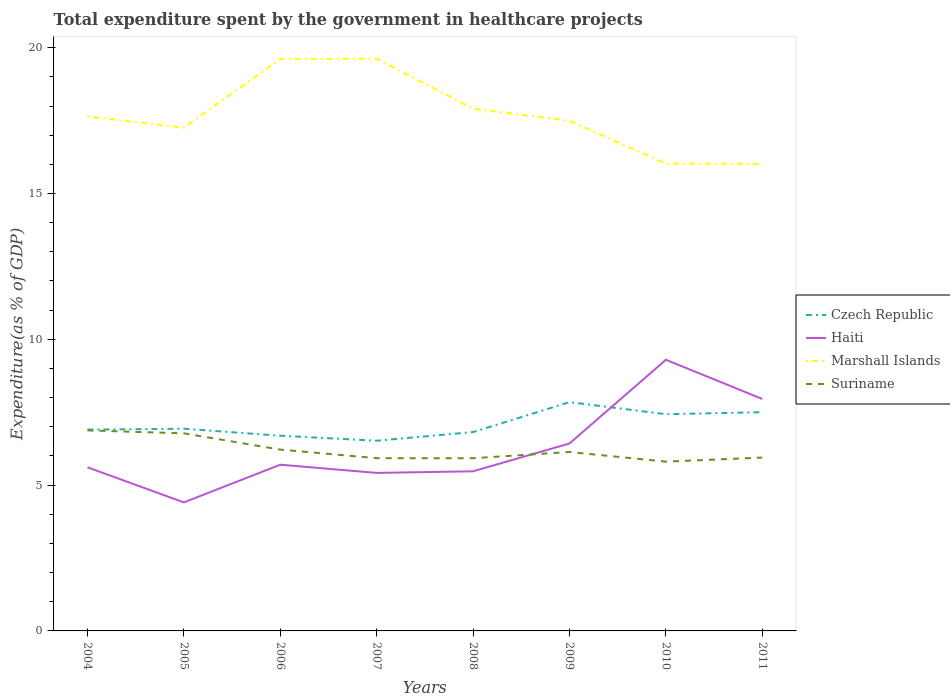Does the line corresponding to Suriname intersect with the line corresponding to Haiti?
Offer a terse response. Yes. Across all years, what is the maximum total expenditure spent by the government in healthcare projects in Marshall Islands?
Offer a terse response. 16.02. In which year was the total expenditure spent by the government in healthcare projects in Haiti maximum?
Your answer should be compact. 2005. What is the total total expenditure spent by the government in healthcare projects in Suriname in the graph?
Your answer should be very brief. 0.41. What is the difference between the highest and the second highest total expenditure spent by the government in healthcare projects in Haiti?
Make the answer very short. 4.89. What is the difference between the highest and the lowest total expenditure spent by the government in healthcare projects in Czech Republic?
Ensure brevity in your answer.  3. Are the values on the major ticks of Y-axis written in scientific E-notation?
Keep it short and to the point. No. Does the graph contain any zero values?
Offer a very short reply. No. Does the graph contain grids?
Your answer should be very brief. No. How many legend labels are there?
Make the answer very short. 4. How are the legend labels stacked?
Offer a very short reply. Vertical. What is the title of the graph?
Provide a succinct answer. Total expenditure spent by the government in healthcare projects. Does "Morocco" appear as one of the legend labels in the graph?
Make the answer very short. No. What is the label or title of the X-axis?
Offer a very short reply. Years. What is the label or title of the Y-axis?
Offer a very short reply. Expenditure(as % of GDP). What is the Expenditure(as % of GDP) of Czech Republic in 2004?
Ensure brevity in your answer.  6.9. What is the Expenditure(as % of GDP) of Haiti in 2004?
Your answer should be compact. 5.61. What is the Expenditure(as % of GDP) in Marshall Islands in 2004?
Offer a very short reply. 17.64. What is the Expenditure(as % of GDP) in Suriname in 2004?
Offer a very short reply. 6.88. What is the Expenditure(as % of GDP) in Czech Republic in 2005?
Keep it short and to the point. 6.93. What is the Expenditure(as % of GDP) of Haiti in 2005?
Offer a terse response. 4.41. What is the Expenditure(as % of GDP) of Marshall Islands in 2005?
Your answer should be compact. 17.26. What is the Expenditure(as % of GDP) in Suriname in 2005?
Make the answer very short. 6.78. What is the Expenditure(as % of GDP) in Czech Republic in 2006?
Make the answer very short. 6.69. What is the Expenditure(as % of GDP) of Haiti in 2006?
Your answer should be compact. 5.7. What is the Expenditure(as % of GDP) of Marshall Islands in 2006?
Keep it short and to the point. 19.62. What is the Expenditure(as % of GDP) of Suriname in 2006?
Offer a terse response. 6.22. What is the Expenditure(as % of GDP) in Czech Republic in 2007?
Offer a terse response. 6.52. What is the Expenditure(as % of GDP) in Haiti in 2007?
Keep it short and to the point. 5.42. What is the Expenditure(as % of GDP) in Marshall Islands in 2007?
Your answer should be very brief. 19.62. What is the Expenditure(as % of GDP) in Suriname in 2007?
Ensure brevity in your answer.  5.92. What is the Expenditure(as % of GDP) in Czech Republic in 2008?
Offer a very short reply. 6.82. What is the Expenditure(as % of GDP) of Haiti in 2008?
Offer a very short reply. 5.47. What is the Expenditure(as % of GDP) of Marshall Islands in 2008?
Offer a terse response. 17.91. What is the Expenditure(as % of GDP) of Suriname in 2008?
Your answer should be compact. 5.92. What is the Expenditure(as % of GDP) in Czech Republic in 2009?
Provide a short and direct response. 7.85. What is the Expenditure(as % of GDP) in Haiti in 2009?
Offer a very short reply. 6.43. What is the Expenditure(as % of GDP) of Marshall Islands in 2009?
Offer a terse response. 17.49. What is the Expenditure(as % of GDP) of Suriname in 2009?
Offer a terse response. 6.14. What is the Expenditure(as % of GDP) of Czech Republic in 2010?
Ensure brevity in your answer.  7.43. What is the Expenditure(as % of GDP) in Haiti in 2010?
Keep it short and to the point. 9.3. What is the Expenditure(as % of GDP) in Marshall Islands in 2010?
Your answer should be very brief. 16.03. What is the Expenditure(as % of GDP) of Suriname in 2010?
Offer a terse response. 5.81. What is the Expenditure(as % of GDP) in Czech Republic in 2011?
Provide a short and direct response. 7.5. What is the Expenditure(as % of GDP) in Haiti in 2011?
Your answer should be compact. 7.95. What is the Expenditure(as % of GDP) of Marshall Islands in 2011?
Make the answer very short. 16.02. What is the Expenditure(as % of GDP) of Suriname in 2011?
Give a very brief answer. 5.94. Across all years, what is the maximum Expenditure(as % of GDP) of Czech Republic?
Make the answer very short. 7.85. Across all years, what is the maximum Expenditure(as % of GDP) in Haiti?
Provide a succinct answer. 9.3. Across all years, what is the maximum Expenditure(as % of GDP) in Marshall Islands?
Offer a terse response. 19.62. Across all years, what is the maximum Expenditure(as % of GDP) in Suriname?
Provide a short and direct response. 6.88. Across all years, what is the minimum Expenditure(as % of GDP) in Czech Republic?
Make the answer very short. 6.52. Across all years, what is the minimum Expenditure(as % of GDP) in Haiti?
Ensure brevity in your answer.  4.41. Across all years, what is the minimum Expenditure(as % of GDP) of Marshall Islands?
Give a very brief answer. 16.02. Across all years, what is the minimum Expenditure(as % of GDP) in Suriname?
Ensure brevity in your answer.  5.81. What is the total Expenditure(as % of GDP) of Czech Republic in the graph?
Keep it short and to the point. 56.65. What is the total Expenditure(as % of GDP) of Haiti in the graph?
Your answer should be very brief. 50.29. What is the total Expenditure(as % of GDP) of Marshall Islands in the graph?
Offer a very short reply. 141.58. What is the total Expenditure(as % of GDP) in Suriname in the graph?
Make the answer very short. 49.6. What is the difference between the Expenditure(as % of GDP) of Czech Republic in 2004 and that in 2005?
Your response must be concise. -0.03. What is the difference between the Expenditure(as % of GDP) in Haiti in 2004 and that in 2005?
Keep it short and to the point. 1.2. What is the difference between the Expenditure(as % of GDP) of Marshall Islands in 2004 and that in 2005?
Your response must be concise. 0.38. What is the difference between the Expenditure(as % of GDP) in Suriname in 2004 and that in 2005?
Your response must be concise. 0.1. What is the difference between the Expenditure(as % of GDP) in Czech Republic in 2004 and that in 2006?
Your answer should be compact. 0.21. What is the difference between the Expenditure(as % of GDP) of Haiti in 2004 and that in 2006?
Make the answer very short. -0.09. What is the difference between the Expenditure(as % of GDP) in Marshall Islands in 2004 and that in 2006?
Your response must be concise. -1.97. What is the difference between the Expenditure(as % of GDP) in Suriname in 2004 and that in 2006?
Provide a short and direct response. 0.66. What is the difference between the Expenditure(as % of GDP) in Czech Republic in 2004 and that in 2007?
Your answer should be compact. 0.38. What is the difference between the Expenditure(as % of GDP) in Haiti in 2004 and that in 2007?
Your answer should be compact. 0.19. What is the difference between the Expenditure(as % of GDP) in Marshall Islands in 2004 and that in 2007?
Your response must be concise. -1.98. What is the difference between the Expenditure(as % of GDP) of Suriname in 2004 and that in 2007?
Offer a terse response. 0.95. What is the difference between the Expenditure(as % of GDP) in Czech Republic in 2004 and that in 2008?
Offer a very short reply. 0.08. What is the difference between the Expenditure(as % of GDP) in Haiti in 2004 and that in 2008?
Your response must be concise. 0.14. What is the difference between the Expenditure(as % of GDP) of Marshall Islands in 2004 and that in 2008?
Offer a terse response. -0.27. What is the difference between the Expenditure(as % of GDP) of Suriname in 2004 and that in 2008?
Offer a terse response. 0.95. What is the difference between the Expenditure(as % of GDP) in Czech Republic in 2004 and that in 2009?
Offer a terse response. -0.94. What is the difference between the Expenditure(as % of GDP) of Haiti in 2004 and that in 2009?
Give a very brief answer. -0.82. What is the difference between the Expenditure(as % of GDP) of Marshall Islands in 2004 and that in 2009?
Provide a succinct answer. 0.15. What is the difference between the Expenditure(as % of GDP) in Suriname in 2004 and that in 2009?
Provide a short and direct response. 0.74. What is the difference between the Expenditure(as % of GDP) in Czech Republic in 2004 and that in 2010?
Make the answer very short. -0.53. What is the difference between the Expenditure(as % of GDP) in Haiti in 2004 and that in 2010?
Your response must be concise. -3.69. What is the difference between the Expenditure(as % of GDP) in Marshall Islands in 2004 and that in 2010?
Make the answer very short. 1.62. What is the difference between the Expenditure(as % of GDP) in Suriname in 2004 and that in 2010?
Your answer should be compact. 1.07. What is the difference between the Expenditure(as % of GDP) of Czech Republic in 2004 and that in 2011?
Make the answer very short. -0.6. What is the difference between the Expenditure(as % of GDP) of Haiti in 2004 and that in 2011?
Make the answer very short. -2.34. What is the difference between the Expenditure(as % of GDP) of Marshall Islands in 2004 and that in 2011?
Your answer should be very brief. 1.62. What is the difference between the Expenditure(as % of GDP) in Suriname in 2004 and that in 2011?
Offer a terse response. 0.93. What is the difference between the Expenditure(as % of GDP) of Czech Republic in 2005 and that in 2006?
Offer a terse response. 0.24. What is the difference between the Expenditure(as % of GDP) in Haiti in 2005 and that in 2006?
Your answer should be very brief. -1.29. What is the difference between the Expenditure(as % of GDP) of Marshall Islands in 2005 and that in 2006?
Give a very brief answer. -2.36. What is the difference between the Expenditure(as % of GDP) in Suriname in 2005 and that in 2006?
Your answer should be compact. 0.56. What is the difference between the Expenditure(as % of GDP) of Czech Republic in 2005 and that in 2007?
Your response must be concise. 0.41. What is the difference between the Expenditure(as % of GDP) in Haiti in 2005 and that in 2007?
Provide a succinct answer. -1.01. What is the difference between the Expenditure(as % of GDP) in Marshall Islands in 2005 and that in 2007?
Provide a short and direct response. -2.36. What is the difference between the Expenditure(as % of GDP) in Suriname in 2005 and that in 2007?
Provide a succinct answer. 0.85. What is the difference between the Expenditure(as % of GDP) of Czech Republic in 2005 and that in 2008?
Provide a short and direct response. 0.12. What is the difference between the Expenditure(as % of GDP) in Haiti in 2005 and that in 2008?
Give a very brief answer. -1.07. What is the difference between the Expenditure(as % of GDP) of Marshall Islands in 2005 and that in 2008?
Your response must be concise. -0.65. What is the difference between the Expenditure(as % of GDP) of Suriname in 2005 and that in 2008?
Provide a short and direct response. 0.85. What is the difference between the Expenditure(as % of GDP) of Czech Republic in 2005 and that in 2009?
Provide a short and direct response. -0.91. What is the difference between the Expenditure(as % of GDP) in Haiti in 2005 and that in 2009?
Ensure brevity in your answer.  -2.02. What is the difference between the Expenditure(as % of GDP) in Marshall Islands in 2005 and that in 2009?
Ensure brevity in your answer.  -0.24. What is the difference between the Expenditure(as % of GDP) of Suriname in 2005 and that in 2009?
Provide a succinct answer. 0.64. What is the difference between the Expenditure(as % of GDP) in Czech Republic in 2005 and that in 2010?
Your response must be concise. -0.5. What is the difference between the Expenditure(as % of GDP) in Haiti in 2005 and that in 2010?
Offer a very short reply. -4.89. What is the difference between the Expenditure(as % of GDP) of Marshall Islands in 2005 and that in 2010?
Your response must be concise. 1.23. What is the difference between the Expenditure(as % of GDP) of Suriname in 2005 and that in 2010?
Your answer should be compact. 0.97. What is the difference between the Expenditure(as % of GDP) of Czech Republic in 2005 and that in 2011?
Give a very brief answer. -0.57. What is the difference between the Expenditure(as % of GDP) in Haiti in 2005 and that in 2011?
Keep it short and to the point. -3.55. What is the difference between the Expenditure(as % of GDP) in Marshall Islands in 2005 and that in 2011?
Your answer should be compact. 1.24. What is the difference between the Expenditure(as % of GDP) in Suriname in 2005 and that in 2011?
Give a very brief answer. 0.83. What is the difference between the Expenditure(as % of GDP) of Czech Republic in 2006 and that in 2007?
Offer a very short reply. 0.17. What is the difference between the Expenditure(as % of GDP) in Haiti in 2006 and that in 2007?
Give a very brief answer. 0.28. What is the difference between the Expenditure(as % of GDP) in Marshall Islands in 2006 and that in 2007?
Provide a succinct answer. -0. What is the difference between the Expenditure(as % of GDP) of Suriname in 2006 and that in 2007?
Keep it short and to the point. 0.29. What is the difference between the Expenditure(as % of GDP) in Czech Republic in 2006 and that in 2008?
Offer a terse response. -0.13. What is the difference between the Expenditure(as % of GDP) of Haiti in 2006 and that in 2008?
Your response must be concise. 0.23. What is the difference between the Expenditure(as % of GDP) of Marshall Islands in 2006 and that in 2008?
Your answer should be compact. 1.71. What is the difference between the Expenditure(as % of GDP) of Suriname in 2006 and that in 2008?
Offer a very short reply. 0.29. What is the difference between the Expenditure(as % of GDP) of Czech Republic in 2006 and that in 2009?
Provide a succinct answer. -1.15. What is the difference between the Expenditure(as % of GDP) of Haiti in 2006 and that in 2009?
Ensure brevity in your answer.  -0.73. What is the difference between the Expenditure(as % of GDP) of Marshall Islands in 2006 and that in 2009?
Your response must be concise. 2.12. What is the difference between the Expenditure(as % of GDP) in Suriname in 2006 and that in 2009?
Provide a succinct answer. 0.08. What is the difference between the Expenditure(as % of GDP) of Czech Republic in 2006 and that in 2010?
Keep it short and to the point. -0.74. What is the difference between the Expenditure(as % of GDP) of Haiti in 2006 and that in 2010?
Your answer should be very brief. -3.6. What is the difference between the Expenditure(as % of GDP) of Marshall Islands in 2006 and that in 2010?
Make the answer very short. 3.59. What is the difference between the Expenditure(as % of GDP) of Suriname in 2006 and that in 2010?
Offer a terse response. 0.41. What is the difference between the Expenditure(as % of GDP) of Czech Republic in 2006 and that in 2011?
Your answer should be very brief. -0.81. What is the difference between the Expenditure(as % of GDP) of Haiti in 2006 and that in 2011?
Offer a very short reply. -2.26. What is the difference between the Expenditure(as % of GDP) of Marshall Islands in 2006 and that in 2011?
Offer a terse response. 3.6. What is the difference between the Expenditure(as % of GDP) in Suriname in 2006 and that in 2011?
Your answer should be very brief. 0.27. What is the difference between the Expenditure(as % of GDP) of Czech Republic in 2007 and that in 2008?
Your answer should be very brief. -0.3. What is the difference between the Expenditure(as % of GDP) in Haiti in 2007 and that in 2008?
Give a very brief answer. -0.06. What is the difference between the Expenditure(as % of GDP) in Marshall Islands in 2007 and that in 2008?
Ensure brevity in your answer.  1.71. What is the difference between the Expenditure(as % of GDP) in Suriname in 2007 and that in 2008?
Provide a short and direct response. 0. What is the difference between the Expenditure(as % of GDP) in Czech Republic in 2007 and that in 2009?
Give a very brief answer. -1.32. What is the difference between the Expenditure(as % of GDP) of Haiti in 2007 and that in 2009?
Make the answer very short. -1.01. What is the difference between the Expenditure(as % of GDP) in Marshall Islands in 2007 and that in 2009?
Make the answer very short. 2.13. What is the difference between the Expenditure(as % of GDP) of Suriname in 2007 and that in 2009?
Offer a terse response. -0.21. What is the difference between the Expenditure(as % of GDP) in Czech Republic in 2007 and that in 2010?
Ensure brevity in your answer.  -0.91. What is the difference between the Expenditure(as % of GDP) in Haiti in 2007 and that in 2010?
Make the answer very short. -3.88. What is the difference between the Expenditure(as % of GDP) of Marshall Islands in 2007 and that in 2010?
Ensure brevity in your answer.  3.59. What is the difference between the Expenditure(as % of GDP) of Suriname in 2007 and that in 2010?
Ensure brevity in your answer.  0.12. What is the difference between the Expenditure(as % of GDP) of Czech Republic in 2007 and that in 2011?
Provide a short and direct response. -0.98. What is the difference between the Expenditure(as % of GDP) of Haiti in 2007 and that in 2011?
Provide a succinct answer. -2.54. What is the difference between the Expenditure(as % of GDP) of Marshall Islands in 2007 and that in 2011?
Offer a very short reply. 3.6. What is the difference between the Expenditure(as % of GDP) in Suriname in 2007 and that in 2011?
Your response must be concise. -0.02. What is the difference between the Expenditure(as % of GDP) of Czech Republic in 2008 and that in 2009?
Make the answer very short. -1.03. What is the difference between the Expenditure(as % of GDP) in Haiti in 2008 and that in 2009?
Keep it short and to the point. -0.95. What is the difference between the Expenditure(as % of GDP) of Marshall Islands in 2008 and that in 2009?
Provide a succinct answer. 0.41. What is the difference between the Expenditure(as % of GDP) of Suriname in 2008 and that in 2009?
Offer a terse response. -0.21. What is the difference between the Expenditure(as % of GDP) in Czech Republic in 2008 and that in 2010?
Provide a short and direct response. -0.61. What is the difference between the Expenditure(as % of GDP) in Haiti in 2008 and that in 2010?
Offer a very short reply. -3.82. What is the difference between the Expenditure(as % of GDP) of Marshall Islands in 2008 and that in 2010?
Offer a terse response. 1.88. What is the difference between the Expenditure(as % of GDP) of Suriname in 2008 and that in 2010?
Provide a short and direct response. 0.12. What is the difference between the Expenditure(as % of GDP) in Czech Republic in 2008 and that in 2011?
Your answer should be compact. -0.68. What is the difference between the Expenditure(as % of GDP) in Haiti in 2008 and that in 2011?
Your answer should be very brief. -2.48. What is the difference between the Expenditure(as % of GDP) in Marshall Islands in 2008 and that in 2011?
Offer a very short reply. 1.89. What is the difference between the Expenditure(as % of GDP) of Suriname in 2008 and that in 2011?
Provide a succinct answer. -0.02. What is the difference between the Expenditure(as % of GDP) in Czech Republic in 2009 and that in 2010?
Offer a terse response. 0.41. What is the difference between the Expenditure(as % of GDP) of Haiti in 2009 and that in 2010?
Offer a very short reply. -2.87. What is the difference between the Expenditure(as % of GDP) of Marshall Islands in 2009 and that in 2010?
Provide a succinct answer. 1.47. What is the difference between the Expenditure(as % of GDP) in Suriname in 2009 and that in 2010?
Ensure brevity in your answer.  0.33. What is the difference between the Expenditure(as % of GDP) of Czech Republic in 2009 and that in 2011?
Your answer should be very brief. 0.34. What is the difference between the Expenditure(as % of GDP) of Haiti in 2009 and that in 2011?
Ensure brevity in your answer.  -1.53. What is the difference between the Expenditure(as % of GDP) in Marshall Islands in 2009 and that in 2011?
Provide a succinct answer. 1.47. What is the difference between the Expenditure(as % of GDP) of Suriname in 2009 and that in 2011?
Offer a very short reply. 0.19. What is the difference between the Expenditure(as % of GDP) of Czech Republic in 2010 and that in 2011?
Give a very brief answer. -0.07. What is the difference between the Expenditure(as % of GDP) of Haiti in 2010 and that in 2011?
Keep it short and to the point. 1.34. What is the difference between the Expenditure(as % of GDP) of Marshall Islands in 2010 and that in 2011?
Give a very brief answer. 0.01. What is the difference between the Expenditure(as % of GDP) in Suriname in 2010 and that in 2011?
Your answer should be very brief. -0.14. What is the difference between the Expenditure(as % of GDP) in Czech Republic in 2004 and the Expenditure(as % of GDP) in Haiti in 2005?
Offer a terse response. 2.5. What is the difference between the Expenditure(as % of GDP) in Czech Republic in 2004 and the Expenditure(as % of GDP) in Marshall Islands in 2005?
Your answer should be very brief. -10.35. What is the difference between the Expenditure(as % of GDP) of Czech Republic in 2004 and the Expenditure(as % of GDP) of Suriname in 2005?
Make the answer very short. 0.13. What is the difference between the Expenditure(as % of GDP) in Haiti in 2004 and the Expenditure(as % of GDP) in Marshall Islands in 2005?
Offer a terse response. -11.65. What is the difference between the Expenditure(as % of GDP) in Haiti in 2004 and the Expenditure(as % of GDP) in Suriname in 2005?
Your answer should be very brief. -1.16. What is the difference between the Expenditure(as % of GDP) of Marshall Islands in 2004 and the Expenditure(as % of GDP) of Suriname in 2005?
Provide a succinct answer. 10.87. What is the difference between the Expenditure(as % of GDP) in Czech Republic in 2004 and the Expenditure(as % of GDP) in Haiti in 2006?
Ensure brevity in your answer.  1.2. What is the difference between the Expenditure(as % of GDP) of Czech Republic in 2004 and the Expenditure(as % of GDP) of Marshall Islands in 2006?
Provide a succinct answer. -12.71. What is the difference between the Expenditure(as % of GDP) in Czech Republic in 2004 and the Expenditure(as % of GDP) in Suriname in 2006?
Your answer should be compact. 0.69. What is the difference between the Expenditure(as % of GDP) in Haiti in 2004 and the Expenditure(as % of GDP) in Marshall Islands in 2006?
Provide a succinct answer. -14.01. What is the difference between the Expenditure(as % of GDP) in Haiti in 2004 and the Expenditure(as % of GDP) in Suriname in 2006?
Offer a terse response. -0.61. What is the difference between the Expenditure(as % of GDP) in Marshall Islands in 2004 and the Expenditure(as % of GDP) in Suriname in 2006?
Make the answer very short. 11.42. What is the difference between the Expenditure(as % of GDP) in Czech Republic in 2004 and the Expenditure(as % of GDP) in Haiti in 2007?
Give a very brief answer. 1.49. What is the difference between the Expenditure(as % of GDP) of Czech Republic in 2004 and the Expenditure(as % of GDP) of Marshall Islands in 2007?
Your answer should be compact. -12.72. What is the difference between the Expenditure(as % of GDP) in Czech Republic in 2004 and the Expenditure(as % of GDP) in Suriname in 2007?
Make the answer very short. 0.98. What is the difference between the Expenditure(as % of GDP) in Haiti in 2004 and the Expenditure(as % of GDP) in Marshall Islands in 2007?
Make the answer very short. -14.01. What is the difference between the Expenditure(as % of GDP) in Haiti in 2004 and the Expenditure(as % of GDP) in Suriname in 2007?
Your answer should be very brief. -0.31. What is the difference between the Expenditure(as % of GDP) in Marshall Islands in 2004 and the Expenditure(as % of GDP) in Suriname in 2007?
Your answer should be very brief. 11.72. What is the difference between the Expenditure(as % of GDP) of Czech Republic in 2004 and the Expenditure(as % of GDP) of Haiti in 2008?
Offer a very short reply. 1.43. What is the difference between the Expenditure(as % of GDP) in Czech Republic in 2004 and the Expenditure(as % of GDP) in Marshall Islands in 2008?
Your response must be concise. -11. What is the difference between the Expenditure(as % of GDP) in Czech Republic in 2004 and the Expenditure(as % of GDP) in Suriname in 2008?
Offer a terse response. 0.98. What is the difference between the Expenditure(as % of GDP) of Haiti in 2004 and the Expenditure(as % of GDP) of Marshall Islands in 2008?
Provide a short and direct response. -12.3. What is the difference between the Expenditure(as % of GDP) of Haiti in 2004 and the Expenditure(as % of GDP) of Suriname in 2008?
Make the answer very short. -0.31. What is the difference between the Expenditure(as % of GDP) of Marshall Islands in 2004 and the Expenditure(as % of GDP) of Suriname in 2008?
Your answer should be compact. 11.72. What is the difference between the Expenditure(as % of GDP) in Czech Republic in 2004 and the Expenditure(as % of GDP) in Haiti in 2009?
Ensure brevity in your answer.  0.48. What is the difference between the Expenditure(as % of GDP) in Czech Republic in 2004 and the Expenditure(as % of GDP) in Marshall Islands in 2009?
Provide a short and direct response. -10.59. What is the difference between the Expenditure(as % of GDP) of Czech Republic in 2004 and the Expenditure(as % of GDP) of Suriname in 2009?
Offer a very short reply. 0.77. What is the difference between the Expenditure(as % of GDP) in Haiti in 2004 and the Expenditure(as % of GDP) in Marshall Islands in 2009?
Your answer should be compact. -11.88. What is the difference between the Expenditure(as % of GDP) of Haiti in 2004 and the Expenditure(as % of GDP) of Suriname in 2009?
Give a very brief answer. -0.52. What is the difference between the Expenditure(as % of GDP) of Marshall Islands in 2004 and the Expenditure(as % of GDP) of Suriname in 2009?
Keep it short and to the point. 11.51. What is the difference between the Expenditure(as % of GDP) of Czech Republic in 2004 and the Expenditure(as % of GDP) of Haiti in 2010?
Provide a succinct answer. -2.39. What is the difference between the Expenditure(as % of GDP) in Czech Republic in 2004 and the Expenditure(as % of GDP) in Marshall Islands in 2010?
Make the answer very short. -9.12. What is the difference between the Expenditure(as % of GDP) of Czech Republic in 2004 and the Expenditure(as % of GDP) of Suriname in 2010?
Keep it short and to the point. 1.1. What is the difference between the Expenditure(as % of GDP) in Haiti in 2004 and the Expenditure(as % of GDP) in Marshall Islands in 2010?
Give a very brief answer. -10.41. What is the difference between the Expenditure(as % of GDP) in Haiti in 2004 and the Expenditure(as % of GDP) in Suriname in 2010?
Offer a terse response. -0.19. What is the difference between the Expenditure(as % of GDP) in Marshall Islands in 2004 and the Expenditure(as % of GDP) in Suriname in 2010?
Give a very brief answer. 11.84. What is the difference between the Expenditure(as % of GDP) of Czech Republic in 2004 and the Expenditure(as % of GDP) of Haiti in 2011?
Provide a succinct answer. -1.05. What is the difference between the Expenditure(as % of GDP) of Czech Republic in 2004 and the Expenditure(as % of GDP) of Marshall Islands in 2011?
Your response must be concise. -9.12. What is the difference between the Expenditure(as % of GDP) in Czech Republic in 2004 and the Expenditure(as % of GDP) in Suriname in 2011?
Provide a succinct answer. 0.96. What is the difference between the Expenditure(as % of GDP) of Haiti in 2004 and the Expenditure(as % of GDP) of Marshall Islands in 2011?
Give a very brief answer. -10.41. What is the difference between the Expenditure(as % of GDP) in Haiti in 2004 and the Expenditure(as % of GDP) in Suriname in 2011?
Keep it short and to the point. -0.33. What is the difference between the Expenditure(as % of GDP) of Marshall Islands in 2004 and the Expenditure(as % of GDP) of Suriname in 2011?
Your answer should be compact. 11.7. What is the difference between the Expenditure(as % of GDP) in Czech Republic in 2005 and the Expenditure(as % of GDP) in Haiti in 2006?
Ensure brevity in your answer.  1.23. What is the difference between the Expenditure(as % of GDP) in Czech Republic in 2005 and the Expenditure(as % of GDP) in Marshall Islands in 2006?
Provide a short and direct response. -12.68. What is the difference between the Expenditure(as % of GDP) of Czech Republic in 2005 and the Expenditure(as % of GDP) of Suriname in 2006?
Provide a short and direct response. 0.72. What is the difference between the Expenditure(as % of GDP) in Haiti in 2005 and the Expenditure(as % of GDP) in Marshall Islands in 2006?
Keep it short and to the point. -15.21. What is the difference between the Expenditure(as % of GDP) of Haiti in 2005 and the Expenditure(as % of GDP) of Suriname in 2006?
Your response must be concise. -1.81. What is the difference between the Expenditure(as % of GDP) of Marshall Islands in 2005 and the Expenditure(as % of GDP) of Suriname in 2006?
Keep it short and to the point. 11.04. What is the difference between the Expenditure(as % of GDP) of Czech Republic in 2005 and the Expenditure(as % of GDP) of Haiti in 2007?
Your answer should be compact. 1.52. What is the difference between the Expenditure(as % of GDP) of Czech Republic in 2005 and the Expenditure(as % of GDP) of Marshall Islands in 2007?
Offer a terse response. -12.69. What is the difference between the Expenditure(as % of GDP) of Haiti in 2005 and the Expenditure(as % of GDP) of Marshall Islands in 2007?
Make the answer very short. -15.21. What is the difference between the Expenditure(as % of GDP) of Haiti in 2005 and the Expenditure(as % of GDP) of Suriname in 2007?
Ensure brevity in your answer.  -1.52. What is the difference between the Expenditure(as % of GDP) of Marshall Islands in 2005 and the Expenditure(as % of GDP) of Suriname in 2007?
Make the answer very short. 11.33. What is the difference between the Expenditure(as % of GDP) of Czech Republic in 2005 and the Expenditure(as % of GDP) of Haiti in 2008?
Your response must be concise. 1.46. What is the difference between the Expenditure(as % of GDP) in Czech Republic in 2005 and the Expenditure(as % of GDP) in Marshall Islands in 2008?
Ensure brevity in your answer.  -10.97. What is the difference between the Expenditure(as % of GDP) in Czech Republic in 2005 and the Expenditure(as % of GDP) in Suriname in 2008?
Your answer should be compact. 1.01. What is the difference between the Expenditure(as % of GDP) in Haiti in 2005 and the Expenditure(as % of GDP) in Marshall Islands in 2008?
Your response must be concise. -13.5. What is the difference between the Expenditure(as % of GDP) in Haiti in 2005 and the Expenditure(as % of GDP) in Suriname in 2008?
Ensure brevity in your answer.  -1.51. What is the difference between the Expenditure(as % of GDP) in Marshall Islands in 2005 and the Expenditure(as % of GDP) in Suriname in 2008?
Provide a short and direct response. 11.33. What is the difference between the Expenditure(as % of GDP) in Czech Republic in 2005 and the Expenditure(as % of GDP) in Haiti in 2009?
Give a very brief answer. 0.51. What is the difference between the Expenditure(as % of GDP) in Czech Republic in 2005 and the Expenditure(as % of GDP) in Marshall Islands in 2009?
Give a very brief answer. -10.56. What is the difference between the Expenditure(as % of GDP) of Czech Republic in 2005 and the Expenditure(as % of GDP) of Suriname in 2009?
Keep it short and to the point. 0.8. What is the difference between the Expenditure(as % of GDP) of Haiti in 2005 and the Expenditure(as % of GDP) of Marshall Islands in 2009?
Give a very brief answer. -13.09. What is the difference between the Expenditure(as % of GDP) in Haiti in 2005 and the Expenditure(as % of GDP) in Suriname in 2009?
Keep it short and to the point. -1.73. What is the difference between the Expenditure(as % of GDP) of Marshall Islands in 2005 and the Expenditure(as % of GDP) of Suriname in 2009?
Your response must be concise. 11.12. What is the difference between the Expenditure(as % of GDP) in Czech Republic in 2005 and the Expenditure(as % of GDP) in Haiti in 2010?
Your response must be concise. -2.36. What is the difference between the Expenditure(as % of GDP) in Czech Republic in 2005 and the Expenditure(as % of GDP) in Marshall Islands in 2010?
Provide a succinct answer. -9.09. What is the difference between the Expenditure(as % of GDP) in Czech Republic in 2005 and the Expenditure(as % of GDP) in Suriname in 2010?
Your response must be concise. 1.13. What is the difference between the Expenditure(as % of GDP) of Haiti in 2005 and the Expenditure(as % of GDP) of Marshall Islands in 2010?
Provide a short and direct response. -11.62. What is the difference between the Expenditure(as % of GDP) of Haiti in 2005 and the Expenditure(as % of GDP) of Suriname in 2010?
Your response must be concise. -1.4. What is the difference between the Expenditure(as % of GDP) in Marshall Islands in 2005 and the Expenditure(as % of GDP) in Suriname in 2010?
Provide a succinct answer. 11.45. What is the difference between the Expenditure(as % of GDP) of Czech Republic in 2005 and the Expenditure(as % of GDP) of Haiti in 2011?
Make the answer very short. -1.02. What is the difference between the Expenditure(as % of GDP) in Czech Republic in 2005 and the Expenditure(as % of GDP) in Marshall Islands in 2011?
Keep it short and to the point. -9.09. What is the difference between the Expenditure(as % of GDP) in Haiti in 2005 and the Expenditure(as % of GDP) in Marshall Islands in 2011?
Your response must be concise. -11.61. What is the difference between the Expenditure(as % of GDP) of Haiti in 2005 and the Expenditure(as % of GDP) of Suriname in 2011?
Your answer should be very brief. -1.54. What is the difference between the Expenditure(as % of GDP) of Marshall Islands in 2005 and the Expenditure(as % of GDP) of Suriname in 2011?
Keep it short and to the point. 11.31. What is the difference between the Expenditure(as % of GDP) of Czech Republic in 2006 and the Expenditure(as % of GDP) of Haiti in 2007?
Provide a succinct answer. 1.28. What is the difference between the Expenditure(as % of GDP) of Czech Republic in 2006 and the Expenditure(as % of GDP) of Marshall Islands in 2007?
Provide a succinct answer. -12.93. What is the difference between the Expenditure(as % of GDP) in Czech Republic in 2006 and the Expenditure(as % of GDP) in Suriname in 2007?
Give a very brief answer. 0.77. What is the difference between the Expenditure(as % of GDP) of Haiti in 2006 and the Expenditure(as % of GDP) of Marshall Islands in 2007?
Provide a succinct answer. -13.92. What is the difference between the Expenditure(as % of GDP) in Haiti in 2006 and the Expenditure(as % of GDP) in Suriname in 2007?
Give a very brief answer. -0.22. What is the difference between the Expenditure(as % of GDP) of Marshall Islands in 2006 and the Expenditure(as % of GDP) of Suriname in 2007?
Make the answer very short. 13.69. What is the difference between the Expenditure(as % of GDP) of Czech Republic in 2006 and the Expenditure(as % of GDP) of Haiti in 2008?
Offer a very short reply. 1.22. What is the difference between the Expenditure(as % of GDP) in Czech Republic in 2006 and the Expenditure(as % of GDP) in Marshall Islands in 2008?
Your answer should be compact. -11.21. What is the difference between the Expenditure(as % of GDP) in Czech Republic in 2006 and the Expenditure(as % of GDP) in Suriname in 2008?
Your response must be concise. 0.77. What is the difference between the Expenditure(as % of GDP) in Haiti in 2006 and the Expenditure(as % of GDP) in Marshall Islands in 2008?
Provide a succinct answer. -12.21. What is the difference between the Expenditure(as % of GDP) in Haiti in 2006 and the Expenditure(as % of GDP) in Suriname in 2008?
Make the answer very short. -0.22. What is the difference between the Expenditure(as % of GDP) in Marshall Islands in 2006 and the Expenditure(as % of GDP) in Suriname in 2008?
Your response must be concise. 13.69. What is the difference between the Expenditure(as % of GDP) in Czech Republic in 2006 and the Expenditure(as % of GDP) in Haiti in 2009?
Offer a very short reply. 0.27. What is the difference between the Expenditure(as % of GDP) of Czech Republic in 2006 and the Expenditure(as % of GDP) of Marshall Islands in 2009?
Your answer should be compact. -10.8. What is the difference between the Expenditure(as % of GDP) in Czech Republic in 2006 and the Expenditure(as % of GDP) in Suriname in 2009?
Provide a succinct answer. 0.56. What is the difference between the Expenditure(as % of GDP) in Haiti in 2006 and the Expenditure(as % of GDP) in Marshall Islands in 2009?
Make the answer very short. -11.79. What is the difference between the Expenditure(as % of GDP) of Haiti in 2006 and the Expenditure(as % of GDP) of Suriname in 2009?
Keep it short and to the point. -0.44. What is the difference between the Expenditure(as % of GDP) in Marshall Islands in 2006 and the Expenditure(as % of GDP) in Suriname in 2009?
Provide a short and direct response. 13.48. What is the difference between the Expenditure(as % of GDP) in Czech Republic in 2006 and the Expenditure(as % of GDP) in Haiti in 2010?
Ensure brevity in your answer.  -2.6. What is the difference between the Expenditure(as % of GDP) in Czech Republic in 2006 and the Expenditure(as % of GDP) in Marshall Islands in 2010?
Give a very brief answer. -9.33. What is the difference between the Expenditure(as % of GDP) of Czech Republic in 2006 and the Expenditure(as % of GDP) of Suriname in 2010?
Your response must be concise. 0.89. What is the difference between the Expenditure(as % of GDP) in Haiti in 2006 and the Expenditure(as % of GDP) in Marshall Islands in 2010?
Your response must be concise. -10.33. What is the difference between the Expenditure(as % of GDP) in Haiti in 2006 and the Expenditure(as % of GDP) in Suriname in 2010?
Your answer should be compact. -0.11. What is the difference between the Expenditure(as % of GDP) of Marshall Islands in 2006 and the Expenditure(as % of GDP) of Suriname in 2010?
Provide a succinct answer. 13.81. What is the difference between the Expenditure(as % of GDP) of Czech Republic in 2006 and the Expenditure(as % of GDP) of Haiti in 2011?
Keep it short and to the point. -1.26. What is the difference between the Expenditure(as % of GDP) in Czech Republic in 2006 and the Expenditure(as % of GDP) in Marshall Islands in 2011?
Provide a succinct answer. -9.33. What is the difference between the Expenditure(as % of GDP) in Czech Republic in 2006 and the Expenditure(as % of GDP) in Suriname in 2011?
Your response must be concise. 0.75. What is the difference between the Expenditure(as % of GDP) of Haiti in 2006 and the Expenditure(as % of GDP) of Marshall Islands in 2011?
Provide a succinct answer. -10.32. What is the difference between the Expenditure(as % of GDP) in Haiti in 2006 and the Expenditure(as % of GDP) in Suriname in 2011?
Ensure brevity in your answer.  -0.24. What is the difference between the Expenditure(as % of GDP) in Marshall Islands in 2006 and the Expenditure(as % of GDP) in Suriname in 2011?
Keep it short and to the point. 13.67. What is the difference between the Expenditure(as % of GDP) in Czech Republic in 2007 and the Expenditure(as % of GDP) in Haiti in 2008?
Offer a very short reply. 1.05. What is the difference between the Expenditure(as % of GDP) in Czech Republic in 2007 and the Expenditure(as % of GDP) in Marshall Islands in 2008?
Give a very brief answer. -11.39. What is the difference between the Expenditure(as % of GDP) of Czech Republic in 2007 and the Expenditure(as % of GDP) of Suriname in 2008?
Offer a very short reply. 0.6. What is the difference between the Expenditure(as % of GDP) of Haiti in 2007 and the Expenditure(as % of GDP) of Marshall Islands in 2008?
Your response must be concise. -12.49. What is the difference between the Expenditure(as % of GDP) of Haiti in 2007 and the Expenditure(as % of GDP) of Suriname in 2008?
Offer a very short reply. -0.5. What is the difference between the Expenditure(as % of GDP) of Marshall Islands in 2007 and the Expenditure(as % of GDP) of Suriname in 2008?
Offer a terse response. 13.7. What is the difference between the Expenditure(as % of GDP) in Czech Republic in 2007 and the Expenditure(as % of GDP) in Haiti in 2009?
Your response must be concise. 0.09. What is the difference between the Expenditure(as % of GDP) in Czech Republic in 2007 and the Expenditure(as % of GDP) in Marshall Islands in 2009?
Offer a terse response. -10.97. What is the difference between the Expenditure(as % of GDP) of Czech Republic in 2007 and the Expenditure(as % of GDP) of Suriname in 2009?
Offer a very short reply. 0.39. What is the difference between the Expenditure(as % of GDP) of Haiti in 2007 and the Expenditure(as % of GDP) of Marshall Islands in 2009?
Ensure brevity in your answer.  -12.08. What is the difference between the Expenditure(as % of GDP) in Haiti in 2007 and the Expenditure(as % of GDP) in Suriname in 2009?
Offer a very short reply. -0.72. What is the difference between the Expenditure(as % of GDP) in Marshall Islands in 2007 and the Expenditure(as % of GDP) in Suriname in 2009?
Make the answer very short. 13.48. What is the difference between the Expenditure(as % of GDP) of Czech Republic in 2007 and the Expenditure(as % of GDP) of Haiti in 2010?
Your answer should be compact. -2.78. What is the difference between the Expenditure(as % of GDP) in Czech Republic in 2007 and the Expenditure(as % of GDP) in Marshall Islands in 2010?
Your answer should be compact. -9.5. What is the difference between the Expenditure(as % of GDP) in Czech Republic in 2007 and the Expenditure(as % of GDP) in Suriname in 2010?
Ensure brevity in your answer.  0.72. What is the difference between the Expenditure(as % of GDP) of Haiti in 2007 and the Expenditure(as % of GDP) of Marshall Islands in 2010?
Your answer should be compact. -10.61. What is the difference between the Expenditure(as % of GDP) of Haiti in 2007 and the Expenditure(as % of GDP) of Suriname in 2010?
Provide a succinct answer. -0.39. What is the difference between the Expenditure(as % of GDP) of Marshall Islands in 2007 and the Expenditure(as % of GDP) of Suriname in 2010?
Give a very brief answer. 13.81. What is the difference between the Expenditure(as % of GDP) of Czech Republic in 2007 and the Expenditure(as % of GDP) of Haiti in 2011?
Provide a succinct answer. -1.43. What is the difference between the Expenditure(as % of GDP) in Czech Republic in 2007 and the Expenditure(as % of GDP) in Marshall Islands in 2011?
Provide a short and direct response. -9.5. What is the difference between the Expenditure(as % of GDP) of Czech Republic in 2007 and the Expenditure(as % of GDP) of Suriname in 2011?
Your answer should be very brief. 0.58. What is the difference between the Expenditure(as % of GDP) in Haiti in 2007 and the Expenditure(as % of GDP) in Marshall Islands in 2011?
Your answer should be compact. -10.6. What is the difference between the Expenditure(as % of GDP) of Haiti in 2007 and the Expenditure(as % of GDP) of Suriname in 2011?
Ensure brevity in your answer.  -0.53. What is the difference between the Expenditure(as % of GDP) in Marshall Islands in 2007 and the Expenditure(as % of GDP) in Suriname in 2011?
Your answer should be very brief. 13.68. What is the difference between the Expenditure(as % of GDP) of Czech Republic in 2008 and the Expenditure(as % of GDP) of Haiti in 2009?
Give a very brief answer. 0.39. What is the difference between the Expenditure(as % of GDP) of Czech Republic in 2008 and the Expenditure(as % of GDP) of Marshall Islands in 2009?
Keep it short and to the point. -10.68. What is the difference between the Expenditure(as % of GDP) of Czech Republic in 2008 and the Expenditure(as % of GDP) of Suriname in 2009?
Make the answer very short. 0.68. What is the difference between the Expenditure(as % of GDP) of Haiti in 2008 and the Expenditure(as % of GDP) of Marshall Islands in 2009?
Offer a very short reply. -12.02. What is the difference between the Expenditure(as % of GDP) in Haiti in 2008 and the Expenditure(as % of GDP) in Suriname in 2009?
Your response must be concise. -0.66. What is the difference between the Expenditure(as % of GDP) in Marshall Islands in 2008 and the Expenditure(as % of GDP) in Suriname in 2009?
Provide a short and direct response. 11.77. What is the difference between the Expenditure(as % of GDP) of Czech Republic in 2008 and the Expenditure(as % of GDP) of Haiti in 2010?
Ensure brevity in your answer.  -2.48. What is the difference between the Expenditure(as % of GDP) of Czech Republic in 2008 and the Expenditure(as % of GDP) of Marshall Islands in 2010?
Offer a terse response. -9.21. What is the difference between the Expenditure(as % of GDP) in Czech Republic in 2008 and the Expenditure(as % of GDP) in Suriname in 2010?
Keep it short and to the point. 1.01. What is the difference between the Expenditure(as % of GDP) in Haiti in 2008 and the Expenditure(as % of GDP) in Marshall Islands in 2010?
Your answer should be very brief. -10.55. What is the difference between the Expenditure(as % of GDP) of Haiti in 2008 and the Expenditure(as % of GDP) of Suriname in 2010?
Make the answer very short. -0.33. What is the difference between the Expenditure(as % of GDP) in Marshall Islands in 2008 and the Expenditure(as % of GDP) in Suriname in 2010?
Give a very brief answer. 12.1. What is the difference between the Expenditure(as % of GDP) in Czech Republic in 2008 and the Expenditure(as % of GDP) in Haiti in 2011?
Keep it short and to the point. -1.14. What is the difference between the Expenditure(as % of GDP) in Czech Republic in 2008 and the Expenditure(as % of GDP) in Marshall Islands in 2011?
Offer a very short reply. -9.2. What is the difference between the Expenditure(as % of GDP) of Czech Republic in 2008 and the Expenditure(as % of GDP) of Suriname in 2011?
Your answer should be very brief. 0.87. What is the difference between the Expenditure(as % of GDP) of Haiti in 2008 and the Expenditure(as % of GDP) of Marshall Islands in 2011?
Ensure brevity in your answer.  -10.55. What is the difference between the Expenditure(as % of GDP) in Haiti in 2008 and the Expenditure(as % of GDP) in Suriname in 2011?
Give a very brief answer. -0.47. What is the difference between the Expenditure(as % of GDP) of Marshall Islands in 2008 and the Expenditure(as % of GDP) of Suriname in 2011?
Offer a terse response. 11.96. What is the difference between the Expenditure(as % of GDP) of Czech Republic in 2009 and the Expenditure(as % of GDP) of Haiti in 2010?
Ensure brevity in your answer.  -1.45. What is the difference between the Expenditure(as % of GDP) of Czech Republic in 2009 and the Expenditure(as % of GDP) of Marshall Islands in 2010?
Provide a succinct answer. -8.18. What is the difference between the Expenditure(as % of GDP) of Czech Republic in 2009 and the Expenditure(as % of GDP) of Suriname in 2010?
Your answer should be compact. 2.04. What is the difference between the Expenditure(as % of GDP) in Haiti in 2009 and the Expenditure(as % of GDP) in Marshall Islands in 2010?
Ensure brevity in your answer.  -9.6. What is the difference between the Expenditure(as % of GDP) in Haiti in 2009 and the Expenditure(as % of GDP) in Suriname in 2010?
Provide a succinct answer. 0.62. What is the difference between the Expenditure(as % of GDP) in Marshall Islands in 2009 and the Expenditure(as % of GDP) in Suriname in 2010?
Give a very brief answer. 11.69. What is the difference between the Expenditure(as % of GDP) in Czech Republic in 2009 and the Expenditure(as % of GDP) in Haiti in 2011?
Offer a terse response. -0.11. What is the difference between the Expenditure(as % of GDP) in Czech Republic in 2009 and the Expenditure(as % of GDP) in Marshall Islands in 2011?
Your answer should be very brief. -8.17. What is the difference between the Expenditure(as % of GDP) in Czech Republic in 2009 and the Expenditure(as % of GDP) in Suriname in 2011?
Your answer should be very brief. 1.9. What is the difference between the Expenditure(as % of GDP) in Haiti in 2009 and the Expenditure(as % of GDP) in Marshall Islands in 2011?
Keep it short and to the point. -9.59. What is the difference between the Expenditure(as % of GDP) in Haiti in 2009 and the Expenditure(as % of GDP) in Suriname in 2011?
Make the answer very short. 0.48. What is the difference between the Expenditure(as % of GDP) in Marshall Islands in 2009 and the Expenditure(as % of GDP) in Suriname in 2011?
Your response must be concise. 11.55. What is the difference between the Expenditure(as % of GDP) of Czech Republic in 2010 and the Expenditure(as % of GDP) of Haiti in 2011?
Offer a very short reply. -0.52. What is the difference between the Expenditure(as % of GDP) of Czech Republic in 2010 and the Expenditure(as % of GDP) of Marshall Islands in 2011?
Provide a short and direct response. -8.59. What is the difference between the Expenditure(as % of GDP) of Czech Republic in 2010 and the Expenditure(as % of GDP) of Suriname in 2011?
Your answer should be very brief. 1.49. What is the difference between the Expenditure(as % of GDP) in Haiti in 2010 and the Expenditure(as % of GDP) in Marshall Islands in 2011?
Your answer should be very brief. -6.72. What is the difference between the Expenditure(as % of GDP) of Haiti in 2010 and the Expenditure(as % of GDP) of Suriname in 2011?
Offer a terse response. 3.35. What is the difference between the Expenditure(as % of GDP) of Marshall Islands in 2010 and the Expenditure(as % of GDP) of Suriname in 2011?
Offer a terse response. 10.08. What is the average Expenditure(as % of GDP) of Czech Republic per year?
Ensure brevity in your answer.  7.08. What is the average Expenditure(as % of GDP) of Haiti per year?
Provide a short and direct response. 6.29. What is the average Expenditure(as % of GDP) in Marshall Islands per year?
Your answer should be compact. 17.7. What is the average Expenditure(as % of GDP) of Suriname per year?
Offer a very short reply. 6.2. In the year 2004, what is the difference between the Expenditure(as % of GDP) of Czech Republic and Expenditure(as % of GDP) of Haiti?
Your answer should be compact. 1.29. In the year 2004, what is the difference between the Expenditure(as % of GDP) of Czech Republic and Expenditure(as % of GDP) of Marshall Islands?
Offer a terse response. -10.74. In the year 2004, what is the difference between the Expenditure(as % of GDP) in Czech Republic and Expenditure(as % of GDP) in Suriname?
Make the answer very short. 0.03. In the year 2004, what is the difference between the Expenditure(as % of GDP) in Haiti and Expenditure(as % of GDP) in Marshall Islands?
Your answer should be very brief. -12.03. In the year 2004, what is the difference between the Expenditure(as % of GDP) of Haiti and Expenditure(as % of GDP) of Suriname?
Offer a very short reply. -1.26. In the year 2004, what is the difference between the Expenditure(as % of GDP) of Marshall Islands and Expenditure(as % of GDP) of Suriname?
Offer a very short reply. 10.77. In the year 2005, what is the difference between the Expenditure(as % of GDP) in Czech Republic and Expenditure(as % of GDP) in Haiti?
Keep it short and to the point. 2.53. In the year 2005, what is the difference between the Expenditure(as % of GDP) in Czech Republic and Expenditure(as % of GDP) in Marshall Islands?
Make the answer very short. -10.32. In the year 2005, what is the difference between the Expenditure(as % of GDP) in Czech Republic and Expenditure(as % of GDP) in Suriname?
Offer a very short reply. 0.16. In the year 2005, what is the difference between the Expenditure(as % of GDP) of Haiti and Expenditure(as % of GDP) of Marshall Islands?
Give a very brief answer. -12.85. In the year 2005, what is the difference between the Expenditure(as % of GDP) of Haiti and Expenditure(as % of GDP) of Suriname?
Make the answer very short. -2.37. In the year 2005, what is the difference between the Expenditure(as % of GDP) of Marshall Islands and Expenditure(as % of GDP) of Suriname?
Your answer should be very brief. 10.48. In the year 2006, what is the difference between the Expenditure(as % of GDP) of Czech Republic and Expenditure(as % of GDP) of Marshall Islands?
Give a very brief answer. -12.92. In the year 2006, what is the difference between the Expenditure(as % of GDP) of Czech Republic and Expenditure(as % of GDP) of Suriname?
Make the answer very short. 0.48. In the year 2006, what is the difference between the Expenditure(as % of GDP) in Haiti and Expenditure(as % of GDP) in Marshall Islands?
Ensure brevity in your answer.  -13.92. In the year 2006, what is the difference between the Expenditure(as % of GDP) in Haiti and Expenditure(as % of GDP) in Suriname?
Provide a succinct answer. -0.52. In the year 2006, what is the difference between the Expenditure(as % of GDP) in Marshall Islands and Expenditure(as % of GDP) in Suriname?
Give a very brief answer. 13.4. In the year 2007, what is the difference between the Expenditure(as % of GDP) in Czech Republic and Expenditure(as % of GDP) in Haiti?
Your answer should be very brief. 1.1. In the year 2007, what is the difference between the Expenditure(as % of GDP) in Czech Republic and Expenditure(as % of GDP) in Marshall Islands?
Ensure brevity in your answer.  -13.1. In the year 2007, what is the difference between the Expenditure(as % of GDP) of Czech Republic and Expenditure(as % of GDP) of Suriname?
Your response must be concise. 0.6. In the year 2007, what is the difference between the Expenditure(as % of GDP) in Haiti and Expenditure(as % of GDP) in Marshall Islands?
Your response must be concise. -14.2. In the year 2007, what is the difference between the Expenditure(as % of GDP) of Haiti and Expenditure(as % of GDP) of Suriname?
Provide a succinct answer. -0.51. In the year 2007, what is the difference between the Expenditure(as % of GDP) of Marshall Islands and Expenditure(as % of GDP) of Suriname?
Provide a succinct answer. 13.7. In the year 2008, what is the difference between the Expenditure(as % of GDP) in Czech Republic and Expenditure(as % of GDP) in Haiti?
Your answer should be compact. 1.34. In the year 2008, what is the difference between the Expenditure(as % of GDP) in Czech Republic and Expenditure(as % of GDP) in Marshall Islands?
Offer a terse response. -11.09. In the year 2008, what is the difference between the Expenditure(as % of GDP) of Czech Republic and Expenditure(as % of GDP) of Suriname?
Offer a terse response. 0.9. In the year 2008, what is the difference between the Expenditure(as % of GDP) in Haiti and Expenditure(as % of GDP) in Marshall Islands?
Your answer should be very brief. -12.43. In the year 2008, what is the difference between the Expenditure(as % of GDP) in Haiti and Expenditure(as % of GDP) in Suriname?
Your answer should be compact. -0.45. In the year 2008, what is the difference between the Expenditure(as % of GDP) of Marshall Islands and Expenditure(as % of GDP) of Suriname?
Ensure brevity in your answer.  11.99. In the year 2009, what is the difference between the Expenditure(as % of GDP) of Czech Republic and Expenditure(as % of GDP) of Haiti?
Your answer should be compact. 1.42. In the year 2009, what is the difference between the Expenditure(as % of GDP) in Czech Republic and Expenditure(as % of GDP) in Marshall Islands?
Offer a very short reply. -9.65. In the year 2009, what is the difference between the Expenditure(as % of GDP) of Czech Republic and Expenditure(as % of GDP) of Suriname?
Provide a short and direct response. 1.71. In the year 2009, what is the difference between the Expenditure(as % of GDP) of Haiti and Expenditure(as % of GDP) of Marshall Islands?
Keep it short and to the point. -11.07. In the year 2009, what is the difference between the Expenditure(as % of GDP) in Haiti and Expenditure(as % of GDP) in Suriname?
Your response must be concise. 0.29. In the year 2009, what is the difference between the Expenditure(as % of GDP) of Marshall Islands and Expenditure(as % of GDP) of Suriname?
Provide a short and direct response. 11.36. In the year 2010, what is the difference between the Expenditure(as % of GDP) in Czech Republic and Expenditure(as % of GDP) in Haiti?
Offer a very short reply. -1.87. In the year 2010, what is the difference between the Expenditure(as % of GDP) of Czech Republic and Expenditure(as % of GDP) of Marshall Islands?
Ensure brevity in your answer.  -8.59. In the year 2010, what is the difference between the Expenditure(as % of GDP) of Czech Republic and Expenditure(as % of GDP) of Suriname?
Your response must be concise. 1.63. In the year 2010, what is the difference between the Expenditure(as % of GDP) in Haiti and Expenditure(as % of GDP) in Marshall Islands?
Give a very brief answer. -6.73. In the year 2010, what is the difference between the Expenditure(as % of GDP) of Haiti and Expenditure(as % of GDP) of Suriname?
Your response must be concise. 3.49. In the year 2010, what is the difference between the Expenditure(as % of GDP) of Marshall Islands and Expenditure(as % of GDP) of Suriname?
Make the answer very short. 10.22. In the year 2011, what is the difference between the Expenditure(as % of GDP) in Czech Republic and Expenditure(as % of GDP) in Haiti?
Your answer should be very brief. -0.45. In the year 2011, what is the difference between the Expenditure(as % of GDP) in Czech Republic and Expenditure(as % of GDP) in Marshall Islands?
Your response must be concise. -8.52. In the year 2011, what is the difference between the Expenditure(as % of GDP) in Czech Republic and Expenditure(as % of GDP) in Suriname?
Keep it short and to the point. 1.56. In the year 2011, what is the difference between the Expenditure(as % of GDP) in Haiti and Expenditure(as % of GDP) in Marshall Islands?
Ensure brevity in your answer.  -8.06. In the year 2011, what is the difference between the Expenditure(as % of GDP) in Haiti and Expenditure(as % of GDP) in Suriname?
Your response must be concise. 2.01. In the year 2011, what is the difference between the Expenditure(as % of GDP) in Marshall Islands and Expenditure(as % of GDP) in Suriname?
Give a very brief answer. 10.08. What is the ratio of the Expenditure(as % of GDP) in Czech Republic in 2004 to that in 2005?
Your answer should be compact. 1. What is the ratio of the Expenditure(as % of GDP) of Haiti in 2004 to that in 2005?
Make the answer very short. 1.27. What is the ratio of the Expenditure(as % of GDP) of Marshall Islands in 2004 to that in 2005?
Offer a terse response. 1.02. What is the ratio of the Expenditure(as % of GDP) in Suriname in 2004 to that in 2005?
Your answer should be compact. 1.01. What is the ratio of the Expenditure(as % of GDP) of Czech Republic in 2004 to that in 2006?
Offer a terse response. 1.03. What is the ratio of the Expenditure(as % of GDP) of Haiti in 2004 to that in 2006?
Offer a terse response. 0.98. What is the ratio of the Expenditure(as % of GDP) of Marshall Islands in 2004 to that in 2006?
Give a very brief answer. 0.9. What is the ratio of the Expenditure(as % of GDP) of Suriname in 2004 to that in 2006?
Offer a terse response. 1.11. What is the ratio of the Expenditure(as % of GDP) in Czech Republic in 2004 to that in 2007?
Offer a terse response. 1.06. What is the ratio of the Expenditure(as % of GDP) of Haiti in 2004 to that in 2007?
Offer a very short reply. 1.04. What is the ratio of the Expenditure(as % of GDP) of Marshall Islands in 2004 to that in 2007?
Make the answer very short. 0.9. What is the ratio of the Expenditure(as % of GDP) of Suriname in 2004 to that in 2007?
Offer a very short reply. 1.16. What is the ratio of the Expenditure(as % of GDP) in Czech Republic in 2004 to that in 2008?
Make the answer very short. 1.01. What is the ratio of the Expenditure(as % of GDP) in Haiti in 2004 to that in 2008?
Offer a very short reply. 1.03. What is the ratio of the Expenditure(as % of GDP) in Marshall Islands in 2004 to that in 2008?
Make the answer very short. 0.99. What is the ratio of the Expenditure(as % of GDP) in Suriname in 2004 to that in 2008?
Provide a short and direct response. 1.16. What is the ratio of the Expenditure(as % of GDP) in Czech Republic in 2004 to that in 2009?
Give a very brief answer. 0.88. What is the ratio of the Expenditure(as % of GDP) in Haiti in 2004 to that in 2009?
Provide a short and direct response. 0.87. What is the ratio of the Expenditure(as % of GDP) of Marshall Islands in 2004 to that in 2009?
Offer a very short reply. 1.01. What is the ratio of the Expenditure(as % of GDP) of Suriname in 2004 to that in 2009?
Offer a terse response. 1.12. What is the ratio of the Expenditure(as % of GDP) of Czech Republic in 2004 to that in 2010?
Offer a very short reply. 0.93. What is the ratio of the Expenditure(as % of GDP) of Haiti in 2004 to that in 2010?
Make the answer very short. 0.6. What is the ratio of the Expenditure(as % of GDP) of Marshall Islands in 2004 to that in 2010?
Your answer should be compact. 1.1. What is the ratio of the Expenditure(as % of GDP) in Suriname in 2004 to that in 2010?
Keep it short and to the point. 1.18. What is the ratio of the Expenditure(as % of GDP) in Czech Republic in 2004 to that in 2011?
Keep it short and to the point. 0.92. What is the ratio of the Expenditure(as % of GDP) of Haiti in 2004 to that in 2011?
Provide a succinct answer. 0.71. What is the ratio of the Expenditure(as % of GDP) of Marshall Islands in 2004 to that in 2011?
Provide a short and direct response. 1.1. What is the ratio of the Expenditure(as % of GDP) of Suriname in 2004 to that in 2011?
Your response must be concise. 1.16. What is the ratio of the Expenditure(as % of GDP) in Czech Republic in 2005 to that in 2006?
Offer a very short reply. 1.04. What is the ratio of the Expenditure(as % of GDP) of Haiti in 2005 to that in 2006?
Keep it short and to the point. 0.77. What is the ratio of the Expenditure(as % of GDP) in Marshall Islands in 2005 to that in 2006?
Ensure brevity in your answer.  0.88. What is the ratio of the Expenditure(as % of GDP) in Suriname in 2005 to that in 2006?
Provide a short and direct response. 1.09. What is the ratio of the Expenditure(as % of GDP) of Czech Republic in 2005 to that in 2007?
Your answer should be very brief. 1.06. What is the ratio of the Expenditure(as % of GDP) in Haiti in 2005 to that in 2007?
Keep it short and to the point. 0.81. What is the ratio of the Expenditure(as % of GDP) in Marshall Islands in 2005 to that in 2007?
Your answer should be compact. 0.88. What is the ratio of the Expenditure(as % of GDP) in Suriname in 2005 to that in 2007?
Your answer should be very brief. 1.14. What is the ratio of the Expenditure(as % of GDP) in Czech Republic in 2005 to that in 2008?
Offer a very short reply. 1.02. What is the ratio of the Expenditure(as % of GDP) of Haiti in 2005 to that in 2008?
Keep it short and to the point. 0.81. What is the ratio of the Expenditure(as % of GDP) in Marshall Islands in 2005 to that in 2008?
Your answer should be very brief. 0.96. What is the ratio of the Expenditure(as % of GDP) of Suriname in 2005 to that in 2008?
Your answer should be very brief. 1.14. What is the ratio of the Expenditure(as % of GDP) in Czech Republic in 2005 to that in 2009?
Your answer should be very brief. 0.88. What is the ratio of the Expenditure(as % of GDP) of Haiti in 2005 to that in 2009?
Give a very brief answer. 0.69. What is the ratio of the Expenditure(as % of GDP) in Marshall Islands in 2005 to that in 2009?
Offer a very short reply. 0.99. What is the ratio of the Expenditure(as % of GDP) of Suriname in 2005 to that in 2009?
Your answer should be very brief. 1.1. What is the ratio of the Expenditure(as % of GDP) in Czech Republic in 2005 to that in 2010?
Offer a very short reply. 0.93. What is the ratio of the Expenditure(as % of GDP) in Haiti in 2005 to that in 2010?
Offer a terse response. 0.47. What is the ratio of the Expenditure(as % of GDP) of Marshall Islands in 2005 to that in 2010?
Make the answer very short. 1.08. What is the ratio of the Expenditure(as % of GDP) of Suriname in 2005 to that in 2010?
Ensure brevity in your answer.  1.17. What is the ratio of the Expenditure(as % of GDP) in Czech Republic in 2005 to that in 2011?
Make the answer very short. 0.92. What is the ratio of the Expenditure(as % of GDP) of Haiti in 2005 to that in 2011?
Make the answer very short. 0.55. What is the ratio of the Expenditure(as % of GDP) in Marshall Islands in 2005 to that in 2011?
Your answer should be compact. 1.08. What is the ratio of the Expenditure(as % of GDP) of Suriname in 2005 to that in 2011?
Ensure brevity in your answer.  1.14. What is the ratio of the Expenditure(as % of GDP) of Czech Republic in 2006 to that in 2007?
Give a very brief answer. 1.03. What is the ratio of the Expenditure(as % of GDP) in Haiti in 2006 to that in 2007?
Make the answer very short. 1.05. What is the ratio of the Expenditure(as % of GDP) of Suriname in 2006 to that in 2007?
Your response must be concise. 1.05. What is the ratio of the Expenditure(as % of GDP) in Czech Republic in 2006 to that in 2008?
Make the answer very short. 0.98. What is the ratio of the Expenditure(as % of GDP) of Haiti in 2006 to that in 2008?
Keep it short and to the point. 1.04. What is the ratio of the Expenditure(as % of GDP) of Marshall Islands in 2006 to that in 2008?
Offer a very short reply. 1.1. What is the ratio of the Expenditure(as % of GDP) of Suriname in 2006 to that in 2008?
Your answer should be very brief. 1.05. What is the ratio of the Expenditure(as % of GDP) of Czech Republic in 2006 to that in 2009?
Give a very brief answer. 0.85. What is the ratio of the Expenditure(as % of GDP) of Haiti in 2006 to that in 2009?
Provide a succinct answer. 0.89. What is the ratio of the Expenditure(as % of GDP) of Marshall Islands in 2006 to that in 2009?
Your response must be concise. 1.12. What is the ratio of the Expenditure(as % of GDP) in Suriname in 2006 to that in 2009?
Make the answer very short. 1.01. What is the ratio of the Expenditure(as % of GDP) in Czech Republic in 2006 to that in 2010?
Provide a short and direct response. 0.9. What is the ratio of the Expenditure(as % of GDP) in Haiti in 2006 to that in 2010?
Offer a terse response. 0.61. What is the ratio of the Expenditure(as % of GDP) in Marshall Islands in 2006 to that in 2010?
Your answer should be very brief. 1.22. What is the ratio of the Expenditure(as % of GDP) of Suriname in 2006 to that in 2010?
Make the answer very short. 1.07. What is the ratio of the Expenditure(as % of GDP) of Czech Republic in 2006 to that in 2011?
Provide a short and direct response. 0.89. What is the ratio of the Expenditure(as % of GDP) in Haiti in 2006 to that in 2011?
Your response must be concise. 0.72. What is the ratio of the Expenditure(as % of GDP) of Marshall Islands in 2006 to that in 2011?
Offer a very short reply. 1.22. What is the ratio of the Expenditure(as % of GDP) of Suriname in 2006 to that in 2011?
Offer a terse response. 1.05. What is the ratio of the Expenditure(as % of GDP) of Czech Republic in 2007 to that in 2008?
Give a very brief answer. 0.96. What is the ratio of the Expenditure(as % of GDP) in Marshall Islands in 2007 to that in 2008?
Offer a very short reply. 1.1. What is the ratio of the Expenditure(as % of GDP) in Czech Republic in 2007 to that in 2009?
Offer a very short reply. 0.83. What is the ratio of the Expenditure(as % of GDP) in Haiti in 2007 to that in 2009?
Make the answer very short. 0.84. What is the ratio of the Expenditure(as % of GDP) of Marshall Islands in 2007 to that in 2009?
Keep it short and to the point. 1.12. What is the ratio of the Expenditure(as % of GDP) in Suriname in 2007 to that in 2009?
Ensure brevity in your answer.  0.97. What is the ratio of the Expenditure(as % of GDP) of Czech Republic in 2007 to that in 2010?
Keep it short and to the point. 0.88. What is the ratio of the Expenditure(as % of GDP) in Haiti in 2007 to that in 2010?
Your answer should be compact. 0.58. What is the ratio of the Expenditure(as % of GDP) in Marshall Islands in 2007 to that in 2010?
Ensure brevity in your answer.  1.22. What is the ratio of the Expenditure(as % of GDP) of Suriname in 2007 to that in 2010?
Your response must be concise. 1.02. What is the ratio of the Expenditure(as % of GDP) of Czech Republic in 2007 to that in 2011?
Your answer should be compact. 0.87. What is the ratio of the Expenditure(as % of GDP) in Haiti in 2007 to that in 2011?
Provide a succinct answer. 0.68. What is the ratio of the Expenditure(as % of GDP) of Marshall Islands in 2007 to that in 2011?
Give a very brief answer. 1.22. What is the ratio of the Expenditure(as % of GDP) in Suriname in 2007 to that in 2011?
Offer a very short reply. 1. What is the ratio of the Expenditure(as % of GDP) in Czech Republic in 2008 to that in 2009?
Offer a terse response. 0.87. What is the ratio of the Expenditure(as % of GDP) of Haiti in 2008 to that in 2009?
Keep it short and to the point. 0.85. What is the ratio of the Expenditure(as % of GDP) in Marshall Islands in 2008 to that in 2009?
Offer a terse response. 1.02. What is the ratio of the Expenditure(as % of GDP) in Suriname in 2008 to that in 2009?
Offer a very short reply. 0.97. What is the ratio of the Expenditure(as % of GDP) of Czech Republic in 2008 to that in 2010?
Make the answer very short. 0.92. What is the ratio of the Expenditure(as % of GDP) of Haiti in 2008 to that in 2010?
Make the answer very short. 0.59. What is the ratio of the Expenditure(as % of GDP) of Marshall Islands in 2008 to that in 2010?
Make the answer very short. 1.12. What is the ratio of the Expenditure(as % of GDP) in Suriname in 2008 to that in 2010?
Your response must be concise. 1.02. What is the ratio of the Expenditure(as % of GDP) in Czech Republic in 2008 to that in 2011?
Your response must be concise. 0.91. What is the ratio of the Expenditure(as % of GDP) in Haiti in 2008 to that in 2011?
Give a very brief answer. 0.69. What is the ratio of the Expenditure(as % of GDP) in Marshall Islands in 2008 to that in 2011?
Keep it short and to the point. 1.12. What is the ratio of the Expenditure(as % of GDP) of Czech Republic in 2009 to that in 2010?
Ensure brevity in your answer.  1.06. What is the ratio of the Expenditure(as % of GDP) of Haiti in 2009 to that in 2010?
Keep it short and to the point. 0.69. What is the ratio of the Expenditure(as % of GDP) of Marshall Islands in 2009 to that in 2010?
Give a very brief answer. 1.09. What is the ratio of the Expenditure(as % of GDP) in Suriname in 2009 to that in 2010?
Make the answer very short. 1.06. What is the ratio of the Expenditure(as % of GDP) in Czech Republic in 2009 to that in 2011?
Provide a succinct answer. 1.05. What is the ratio of the Expenditure(as % of GDP) of Haiti in 2009 to that in 2011?
Provide a succinct answer. 0.81. What is the ratio of the Expenditure(as % of GDP) of Marshall Islands in 2009 to that in 2011?
Ensure brevity in your answer.  1.09. What is the ratio of the Expenditure(as % of GDP) of Suriname in 2009 to that in 2011?
Offer a terse response. 1.03. What is the ratio of the Expenditure(as % of GDP) of Haiti in 2010 to that in 2011?
Your response must be concise. 1.17. What is the ratio of the Expenditure(as % of GDP) in Marshall Islands in 2010 to that in 2011?
Provide a succinct answer. 1. What is the ratio of the Expenditure(as % of GDP) of Suriname in 2010 to that in 2011?
Ensure brevity in your answer.  0.98. What is the difference between the highest and the second highest Expenditure(as % of GDP) of Czech Republic?
Give a very brief answer. 0.34. What is the difference between the highest and the second highest Expenditure(as % of GDP) of Haiti?
Ensure brevity in your answer.  1.34. What is the difference between the highest and the second highest Expenditure(as % of GDP) of Marshall Islands?
Provide a short and direct response. 0. What is the difference between the highest and the second highest Expenditure(as % of GDP) of Suriname?
Make the answer very short. 0.1. What is the difference between the highest and the lowest Expenditure(as % of GDP) of Czech Republic?
Make the answer very short. 1.32. What is the difference between the highest and the lowest Expenditure(as % of GDP) of Haiti?
Provide a succinct answer. 4.89. What is the difference between the highest and the lowest Expenditure(as % of GDP) in Marshall Islands?
Provide a succinct answer. 3.6. What is the difference between the highest and the lowest Expenditure(as % of GDP) of Suriname?
Your answer should be very brief. 1.07. 